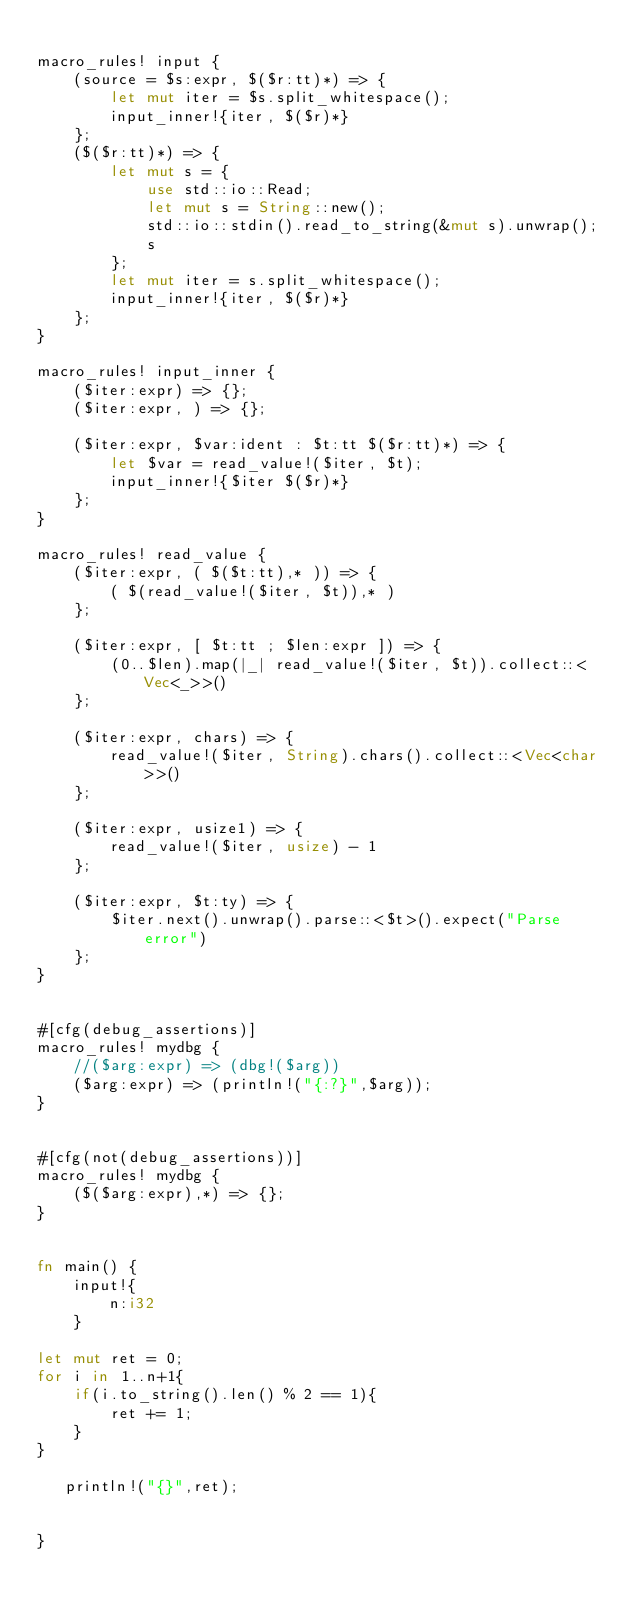<code> <loc_0><loc_0><loc_500><loc_500><_Rust_>
macro_rules! input {
    (source = $s:expr, $($r:tt)*) => {
        let mut iter = $s.split_whitespace();
        input_inner!{iter, $($r)*}
    };
    ($($r:tt)*) => {
        let mut s = {
            use std::io::Read;
            let mut s = String::new();
            std::io::stdin().read_to_string(&mut s).unwrap();
            s
        };
        let mut iter = s.split_whitespace();
        input_inner!{iter, $($r)*}
    };
}

macro_rules! input_inner {
    ($iter:expr) => {};
    ($iter:expr, ) => {};

    ($iter:expr, $var:ident : $t:tt $($r:tt)*) => {
        let $var = read_value!($iter, $t);
        input_inner!{$iter $($r)*}
    };
}

macro_rules! read_value {
    ($iter:expr, ( $($t:tt),* )) => {
        ( $(read_value!($iter, $t)),* )
    };

    ($iter:expr, [ $t:tt ; $len:expr ]) => {
        (0..$len).map(|_| read_value!($iter, $t)).collect::<Vec<_>>()
    };

    ($iter:expr, chars) => {
        read_value!($iter, String).chars().collect::<Vec<char>>()
    };

    ($iter:expr, usize1) => {
        read_value!($iter, usize) - 1
    };

    ($iter:expr, $t:ty) => {
        $iter.next().unwrap().parse::<$t>().expect("Parse error")
    };
}


#[cfg(debug_assertions)]
macro_rules! mydbg {
    //($arg:expr) => (dbg!($arg))
    ($arg:expr) => (println!("{:?}",$arg));
}


#[cfg(not(debug_assertions))]
macro_rules! mydbg {
    ($($arg:expr),*) => {};
}


fn main() {
    input!{
        n:i32
    }

let mut ret = 0;
for i in 1..n+1{
    if(i.to_string().len() % 2 == 1){
        ret += 1;
    }
}
   
   println!("{}",ret);


}
</code> 